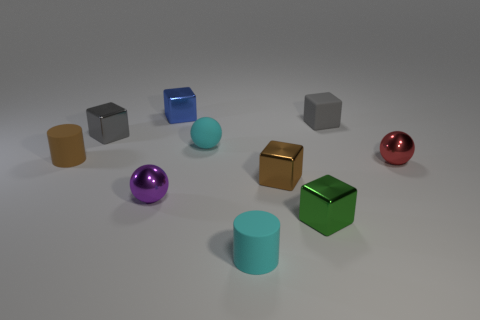There is a red object that is the same shape as the tiny purple thing; what is its size?
Offer a terse response. Small. What is the color of the other small metal thing that is the same shape as the red metal object?
Your response must be concise. Purple. Are any blue shiny cylinders visible?
Give a very brief answer. No. What is the color of the shiny cube to the left of the shiny ball that is on the left side of the small gray matte object?
Your answer should be very brief. Gray. How many other things are the same color as the matte cube?
Your answer should be compact. 1. What number of things are either small gray cylinders or gray objects to the left of the purple shiny sphere?
Offer a very short reply. 1. The small sphere that is in front of the tiny red object is what color?
Your answer should be compact. Purple. What is the shape of the small brown shiny thing?
Your answer should be compact. Cube. What is the brown thing in front of the shiny ball right of the cyan matte sphere made of?
Your answer should be very brief. Metal. How many other objects are the same material as the brown cylinder?
Give a very brief answer. 3. 